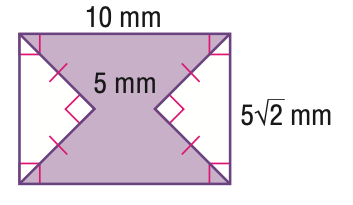Answer the mathemtical geometry problem and directly provide the correct option letter.
Question: Find the area of the shaded region. Round to the nearest tenth if necessary.
Choices: A: 20.7 B: 45.7 C: 50 D: 70.7 B 